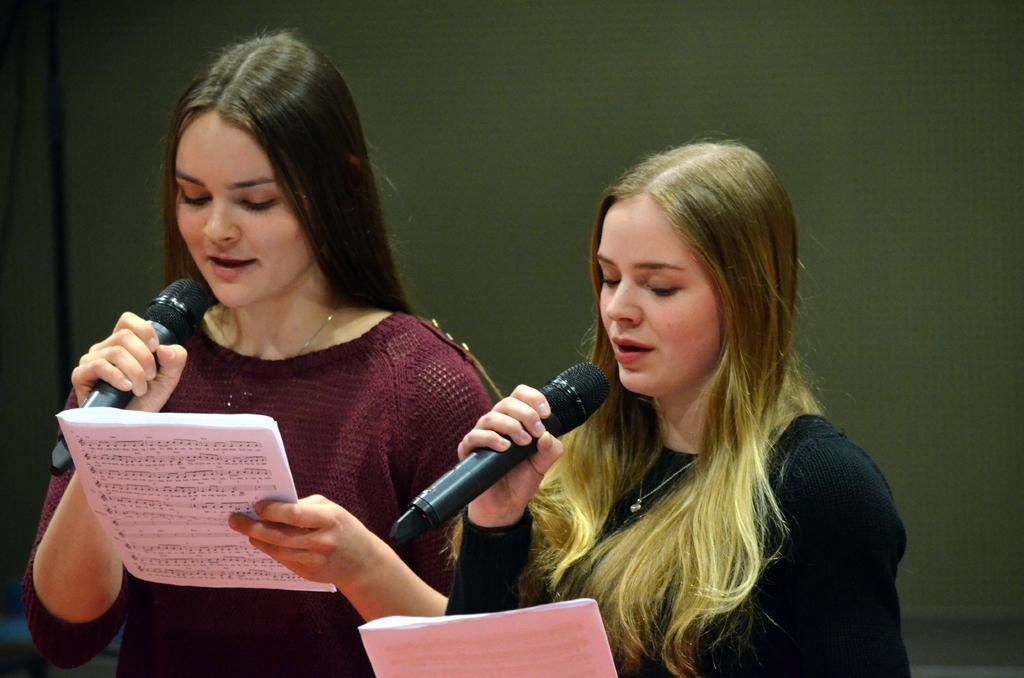In one or two sentences, can you explain what this image depicts? In this image there are two persons wearing colorful clothes. These two persons holding mic and paper. 